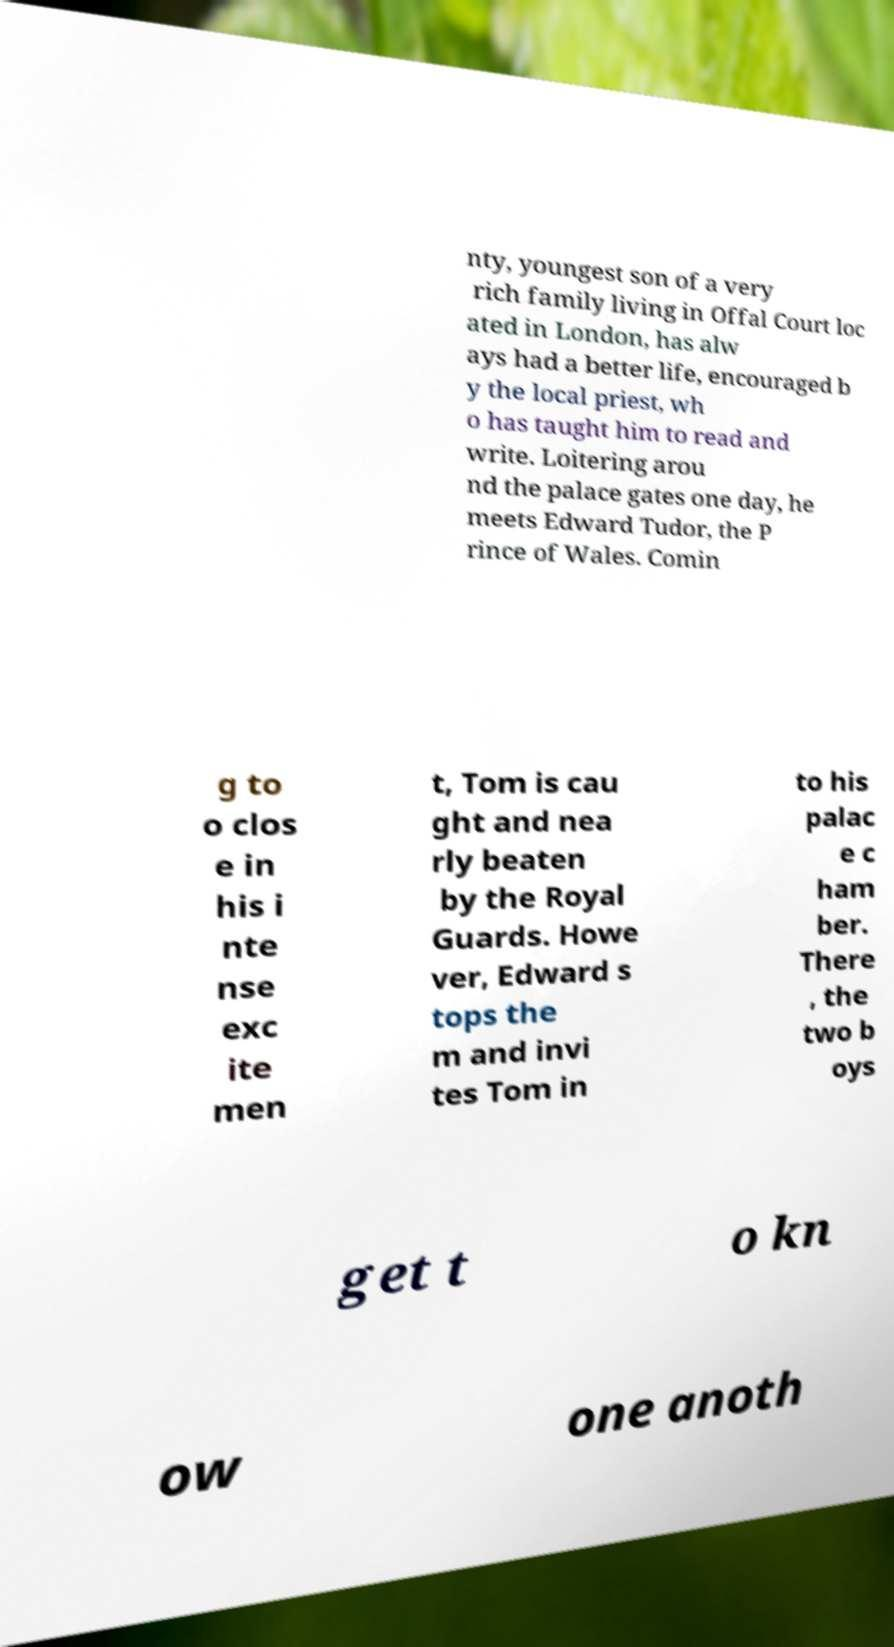Please identify and transcribe the text found in this image. nty, youngest son of a very rich family living in Offal Court loc ated in London, has alw ays had a better life, encouraged b y the local priest, wh o has taught him to read and write. Loitering arou nd the palace gates one day, he meets Edward Tudor, the P rince of Wales. Comin g to o clos e in his i nte nse exc ite men t, Tom is cau ght and nea rly beaten by the Royal Guards. Howe ver, Edward s tops the m and invi tes Tom in to his palac e c ham ber. There , the two b oys get t o kn ow one anoth 